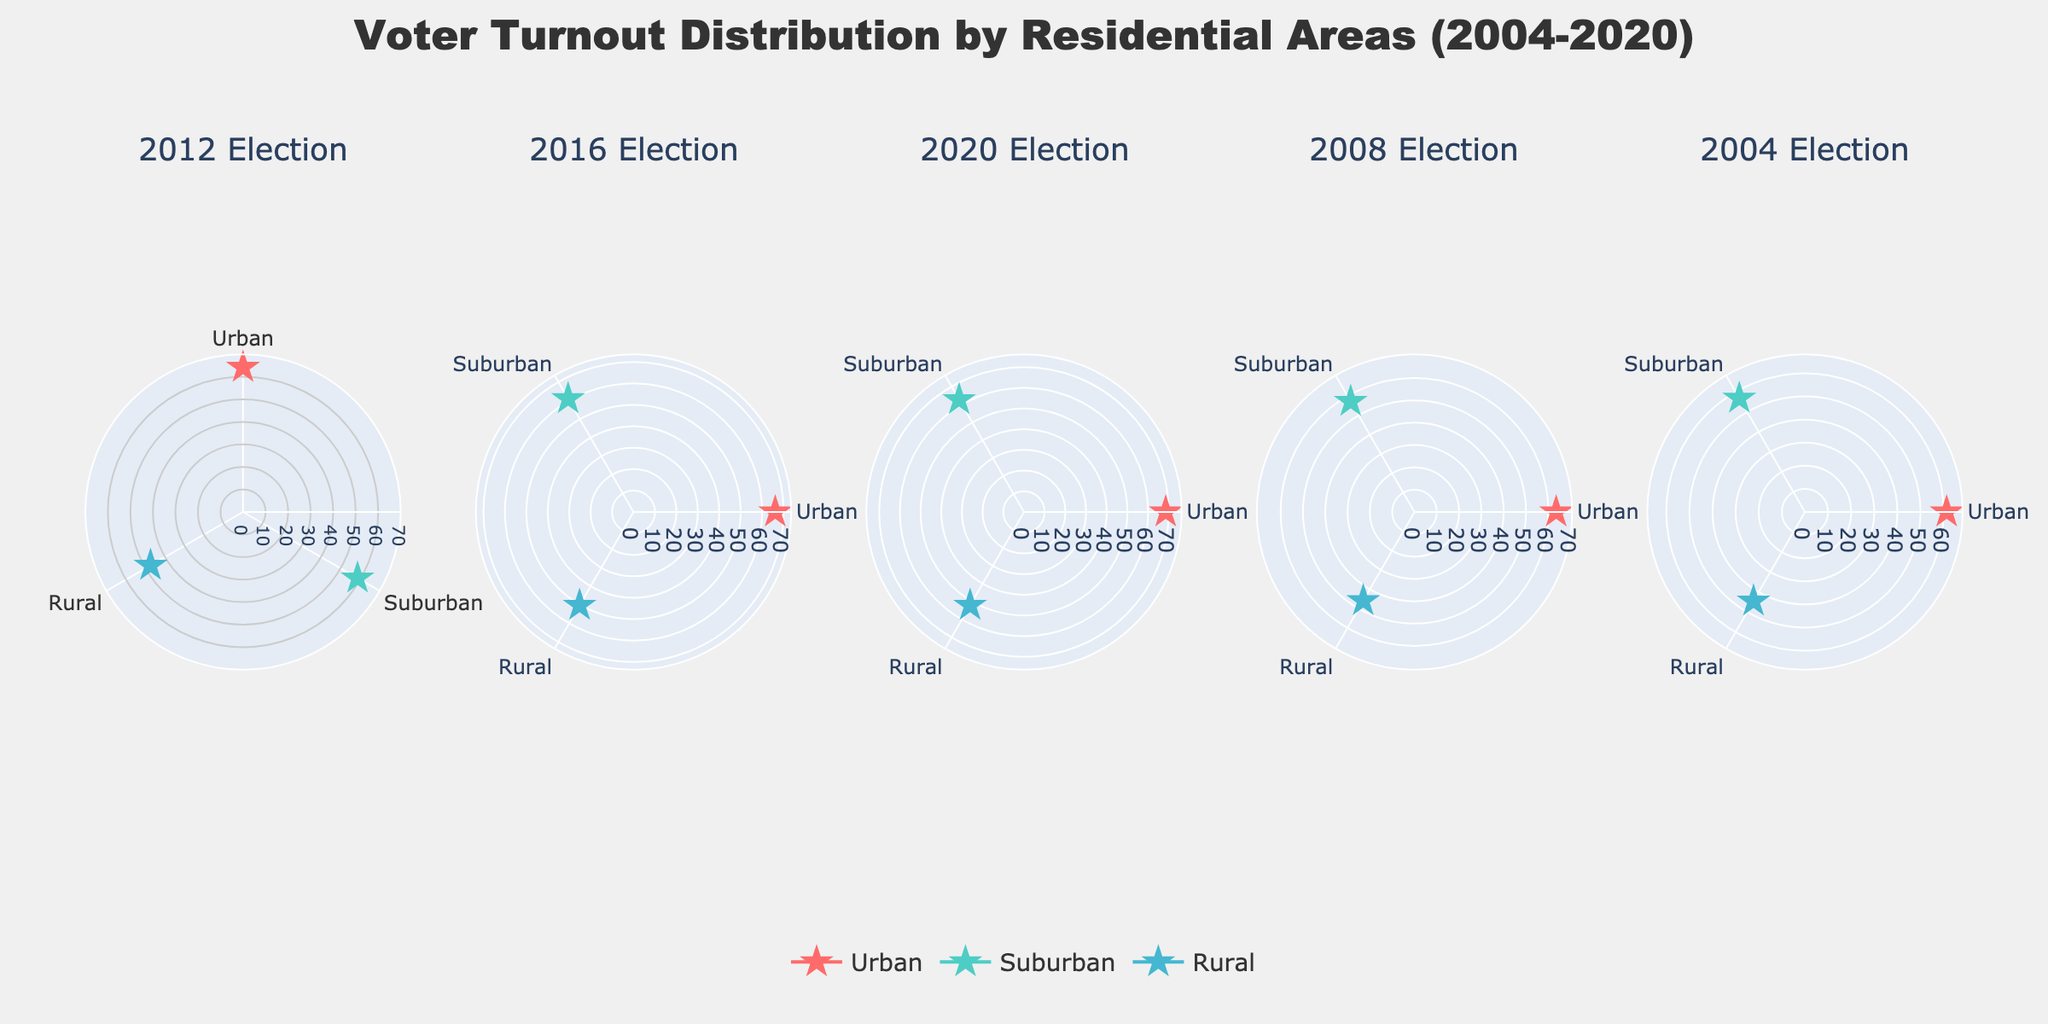What's the title of the figure? The title is typically displayed at the top of the plot, providing an overview of what the figure is about. In this case, it reads "Voter Turnout Distribution by Residential Areas (2004-2020)".
Answer: Voter Turnout Distribution by Residential Areas (2004-2020) In which year did Urban areas have the highest voter turnout? To determine this, look at the sections labeled "Urban" in each subplot (each section representing a year). Compare the values to find the year with the highest percentage.
Answer: 2020 Compare the voter turnout in Rural areas between 2004 and 2020. Which year had a higher turnout and by how much? In Rural areas, the turnout was 44.5% in 2004 and 52.1% in 2020. The difference is 52.1 - 44.5.
Answer: 2020 by 7.6% What is the average voter turnout for Suburban areas across all the years displayed? Add the voter turnout percentages for Suburban areas in all the years (58.7 + 61.0 + 62.7 + 57.2 + 56.8) and divide by the number of years (5). The calculation would be (58.7 + 61.0 + 62.7 + 57.2 + 56.8) / 5.
Answer: 59.28 Which residential area consistently had the lowest voter turnout across all the years? Look at the voter turnout percentages for each residential area (Urban, Suburban, Rural) in each subplot and determine which one has the lowest values across all subplots.
Answer: Rural How much did the voter turnout in Urban areas change from 2008 to 2016? Voter turnout in Urban areas was 63.5% in 2008 and 66.1% in 2016. Subtract the 2008 value from the 2016 value (66.1 - 63.5).
Answer: Increased by 2.6% Which election year had the most significant increase in voter turnout for Suburban areas compared to the previous election? Calculate the differences between consecutive years for Suburban areas:  
2012 - 2008: 58.7 - 57.2 = 1.5  
2016 - 2012: 61.0 - 58.7 = 2.3  
2020 - 2016: 62.7 - 61.0 = 1.7  
2008 - 2004: 57.2 - 56.8 = 0.4  
The largest difference is between 2012 and 2016.
Answer: 2016 with an increase of 2.3% What percentage of voter turnout for Rural areas was in the 2012 election? Look at the subplot for the 2012 election year and find the percentage for the Rural section.
Answer: 47.4% During which election year did Suburban areas have a turnout of over 60%? Look under the Suburban section in each subplot and find the years when the percentage is over 60%:  
2016: 61.0%  
2020: 62.7%
Answer: 2016 and 2020 